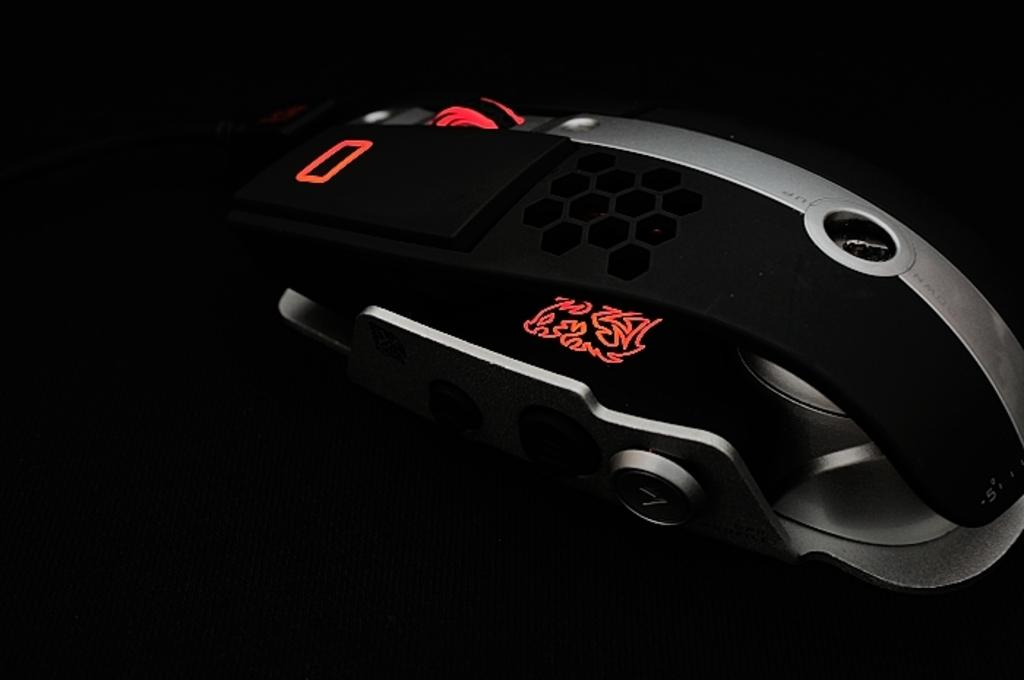What can be seen in the image? There is an object in the image. What color is the background of the image? The background of the image is black. What type of nation is depicted in the image? There is no nation depicted in the image, as it only contains an object and a black background. Can you tell me how many firemen are present in the image? There are no firemen present in the image; it only contains an object and a black background. 